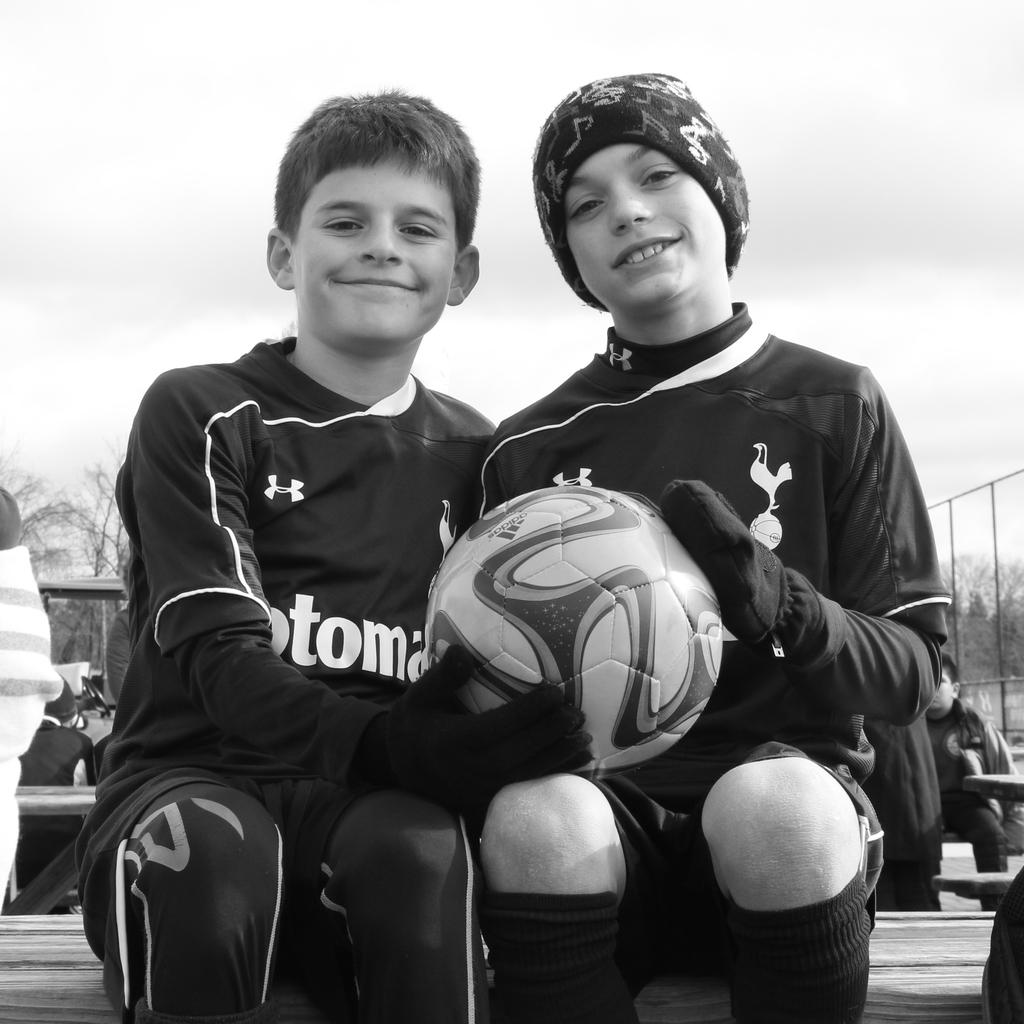How many kids are in the image? There are two kids in the image. What are the kids doing in the image? The kids are sitting on a table and holding a ball. Can you describe the group of people in the image? The group of people is sitting behind the kids. What type of finger can be seen in the image? There is no finger visible in the image. What type of farm equipment is being used by the farmer in the image? There is no farmer or farm equipment present in the image. 